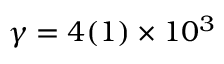Convert formula to latex. <formula><loc_0><loc_0><loc_500><loc_500>\gamma = 4 ( 1 ) \times 1 0 ^ { 3 }</formula> 